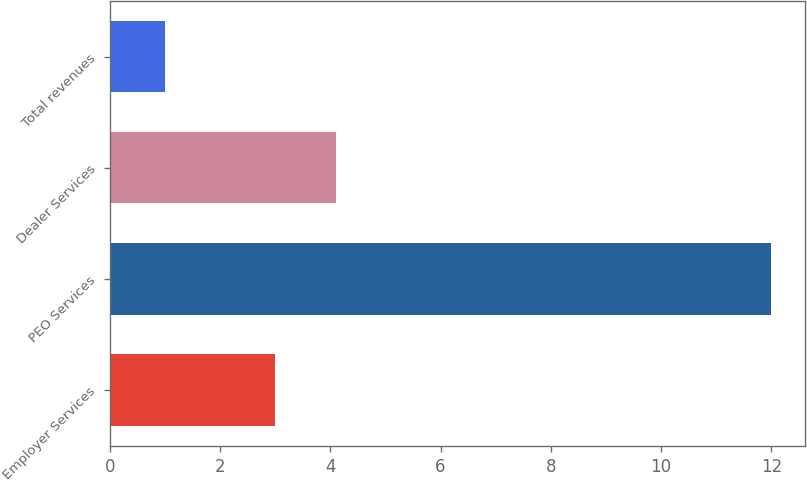Convert chart to OTSL. <chart><loc_0><loc_0><loc_500><loc_500><bar_chart><fcel>Employer Services<fcel>PEO Services<fcel>Dealer Services<fcel>Total revenues<nl><fcel>3<fcel>12<fcel>4.1<fcel>1<nl></chart> 